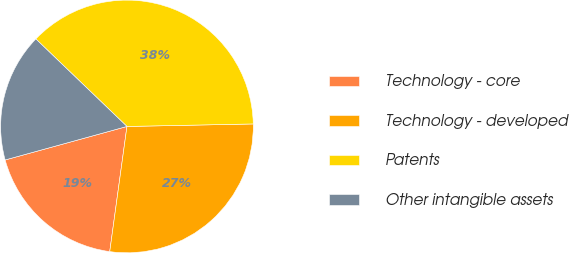<chart> <loc_0><loc_0><loc_500><loc_500><pie_chart><fcel>Technology - core<fcel>Technology - developed<fcel>Patents<fcel>Other intangible assets<nl><fcel>18.55%<fcel>27.49%<fcel>37.5%<fcel>16.45%<nl></chart> 